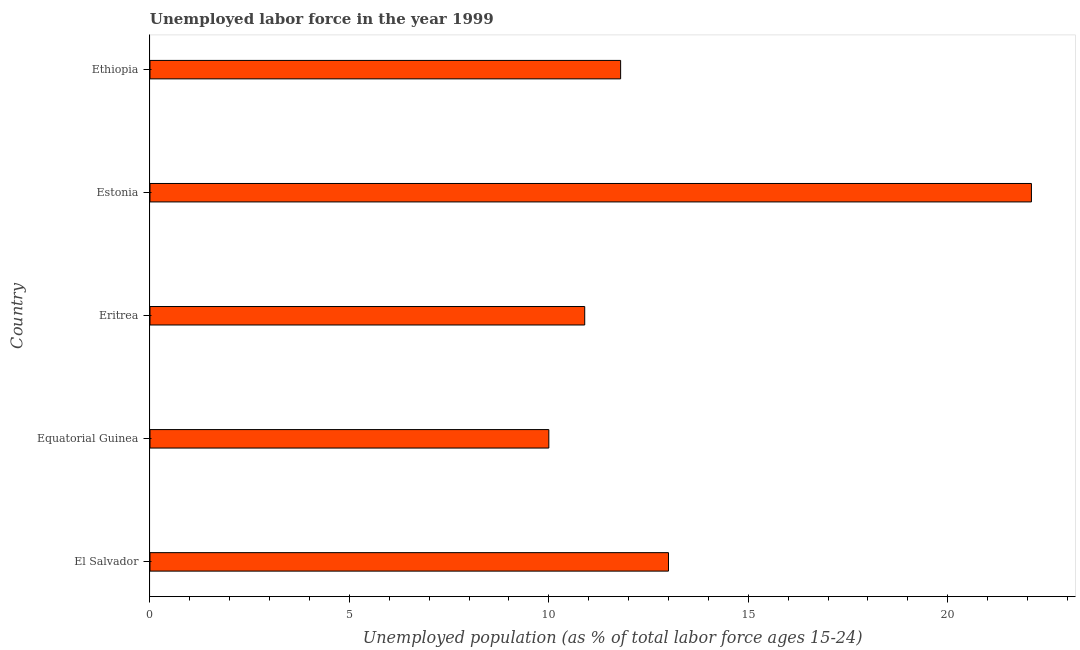Does the graph contain any zero values?
Offer a terse response. No. Does the graph contain grids?
Your answer should be very brief. No. What is the title of the graph?
Give a very brief answer. Unemployed labor force in the year 1999. What is the label or title of the X-axis?
Ensure brevity in your answer.  Unemployed population (as % of total labor force ages 15-24). What is the label or title of the Y-axis?
Ensure brevity in your answer.  Country. What is the total unemployed youth population in Eritrea?
Provide a short and direct response. 10.9. Across all countries, what is the maximum total unemployed youth population?
Ensure brevity in your answer.  22.1. In which country was the total unemployed youth population maximum?
Give a very brief answer. Estonia. In which country was the total unemployed youth population minimum?
Provide a succinct answer. Equatorial Guinea. What is the sum of the total unemployed youth population?
Provide a short and direct response. 67.8. What is the average total unemployed youth population per country?
Offer a terse response. 13.56. What is the median total unemployed youth population?
Give a very brief answer. 11.8. What is the ratio of the total unemployed youth population in El Salvador to that in Ethiopia?
Your response must be concise. 1.1. Is the difference between the total unemployed youth population in Eritrea and Estonia greater than the difference between any two countries?
Make the answer very short. No. What is the difference between the highest and the lowest total unemployed youth population?
Your response must be concise. 12.1. In how many countries, is the total unemployed youth population greater than the average total unemployed youth population taken over all countries?
Your answer should be compact. 1. How many bars are there?
Your answer should be compact. 5. Are all the bars in the graph horizontal?
Offer a very short reply. Yes. How many countries are there in the graph?
Make the answer very short. 5. What is the Unemployed population (as % of total labor force ages 15-24) in El Salvador?
Your answer should be very brief. 13. What is the Unemployed population (as % of total labor force ages 15-24) in Equatorial Guinea?
Make the answer very short. 10. What is the Unemployed population (as % of total labor force ages 15-24) of Eritrea?
Provide a succinct answer. 10.9. What is the Unemployed population (as % of total labor force ages 15-24) in Estonia?
Make the answer very short. 22.1. What is the Unemployed population (as % of total labor force ages 15-24) in Ethiopia?
Your answer should be compact. 11.8. What is the difference between the Unemployed population (as % of total labor force ages 15-24) in El Salvador and Eritrea?
Offer a terse response. 2.1. What is the difference between the Unemployed population (as % of total labor force ages 15-24) in El Salvador and Estonia?
Keep it short and to the point. -9.1. What is the difference between the Unemployed population (as % of total labor force ages 15-24) in Equatorial Guinea and Eritrea?
Provide a succinct answer. -0.9. What is the difference between the Unemployed population (as % of total labor force ages 15-24) in Equatorial Guinea and Estonia?
Your response must be concise. -12.1. What is the difference between the Unemployed population (as % of total labor force ages 15-24) in Equatorial Guinea and Ethiopia?
Your answer should be very brief. -1.8. What is the difference between the Unemployed population (as % of total labor force ages 15-24) in Eritrea and Estonia?
Provide a succinct answer. -11.2. What is the difference between the Unemployed population (as % of total labor force ages 15-24) in Eritrea and Ethiopia?
Offer a very short reply. -0.9. What is the ratio of the Unemployed population (as % of total labor force ages 15-24) in El Salvador to that in Equatorial Guinea?
Offer a terse response. 1.3. What is the ratio of the Unemployed population (as % of total labor force ages 15-24) in El Salvador to that in Eritrea?
Ensure brevity in your answer.  1.19. What is the ratio of the Unemployed population (as % of total labor force ages 15-24) in El Salvador to that in Estonia?
Provide a short and direct response. 0.59. What is the ratio of the Unemployed population (as % of total labor force ages 15-24) in El Salvador to that in Ethiopia?
Your answer should be very brief. 1.1. What is the ratio of the Unemployed population (as % of total labor force ages 15-24) in Equatorial Guinea to that in Eritrea?
Your answer should be compact. 0.92. What is the ratio of the Unemployed population (as % of total labor force ages 15-24) in Equatorial Guinea to that in Estonia?
Provide a short and direct response. 0.45. What is the ratio of the Unemployed population (as % of total labor force ages 15-24) in Equatorial Guinea to that in Ethiopia?
Make the answer very short. 0.85. What is the ratio of the Unemployed population (as % of total labor force ages 15-24) in Eritrea to that in Estonia?
Offer a terse response. 0.49. What is the ratio of the Unemployed population (as % of total labor force ages 15-24) in Eritrea to that in Ethiopia?
Your answer should be very brief. 0.92. What is the ratio of the Unemployed population (as % of total labor force ages 15-24) in Estonia to that in Ethiopia?
Ensure brevity in your answer.  1.87. 